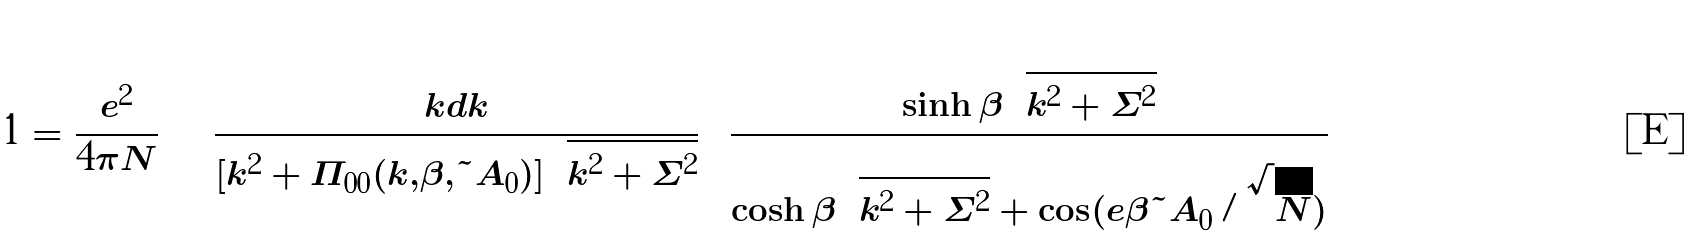<formula> <loc_0><loc_0><loc_500><loc_500>1 = \frac { e ^ { 2 } } { 4 \pi N } \int \frac { k d k } { [ k ^ { 2 } + \Pi _ { 0 0 } ( k , \beta , \tilde { A } _ { 0 } ) ] \sqrt { k ^ { 2 } + \Sigma ^ { 2 } } } \left [ \frac { \sinh \beta \sqrt { k ^ { 2 } + \Sigma ^ { 2 } } } { \cosh \beta \sqrt { k ^ { 2 } + \Sigma ^ { 2 } } + \cos ( e \beta \tilde { A } _ { 0 } / \sqrt { N } ) } \right ]</formula> 